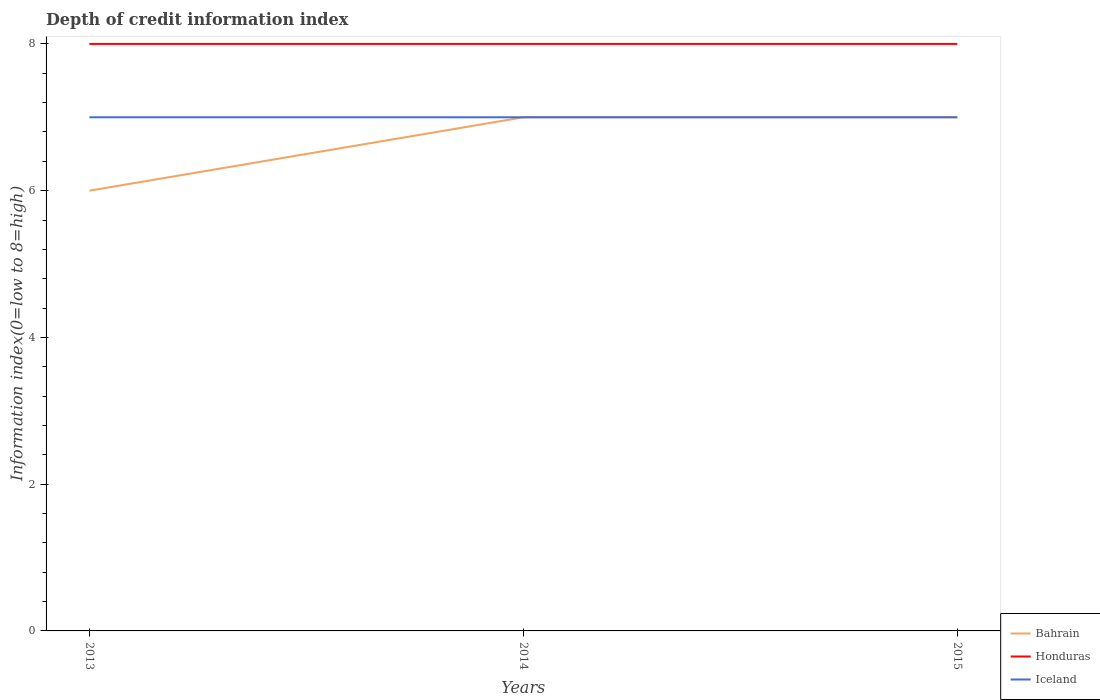How many different coloured lines are there?
Your answer should be very brief. 3. Across all years, what is the maximum information index in Bahrain?
Your answer should be compact. 6. What is the total information index in Bahrain in the graph?
Your response must be concise. 0. What is the difference between the highest and the second highest information index in Bahrain?
Make the answer very short. 1. What is the difference between the highest and the lowest information index in Honduras?
Your answer should be compact. 0. Does the graph contain grids?
Keep it short and to the point. No. Where does the legend appear in the graph?
Keep it short and to the point. Bottom right. How many legend labels are there?
Your answer should be very brief. 3. What is the title of the graph?
Give a very brief answer. Depth of credit information index. What is the label or title of the X-axis?
Offer a terse response. Years. What is the label or title of the Y-axis?
Give a very brief answer. Information index(0=low to 8=high). What is the Information index(0=low to 8=high) in Bahrain in 2013?
Offer a very short reply. 6. What is the Information index(0=low to 8=high) in Iceland in 2013?
Provide a succinct answer. 7. What is the Information index(0=low to 8=high) in Bahrain in 2014?
Provide a succinct answer. 7. What is the Information index(0=low to 8=high) in Honduras in 2014?
Your answer should be very brief. 8. What is the Information index(0=low to 8=high) of Iceland in 2014?
Offer a terse response. 7. What is the Information index(0=low to 8=high) of Bahrain in 2015?
Your response must be concise. 7. What is the Information index(0=low to 8=high) in Honduras in 2015?
Keep it short and to the point. 8. What is the total Information index(0=low to 8=high) of Honduras in the graph?
Ensure brevity in your answer.  24. What is the difference between the Information index(0=low to 8=high) in Bahrain in 2013 and that in 2014?
Provide a succinct answer. -1. What is the difference between the Information index(0=low to 8=high) of Bahrain in 2013 and that in 2015?
Keep it short and to the point. -1. What is the difference between the Information index(0=low to 8=high) of Honduras in 2013 and that in 2015?
Ensure brevity in your answer.  0. What is the difference between the Information index(0=low to 8=high) in Iceland in 2013 and that in 2015?
Make the answer very short. 0. What is the difference between the Information index(0=low to 8=high) in Honduras in 2014 and that in 2015?
Provide a short and direct response. 0. What is the difference between the Information index(0=low to 8=high) of Iceland in 2014 and that in 2015?
Your response must be concise. 0. What is the difference between the Information index(0=low to 8=high) in Bahrain in 2013 and the Information index(0=low to 8=high) in Honduras in 2014?
Your response must be concise. -2. What is the difference between the Information index(0=low to 8=high) in Bahrain in 2013 and the Information index(0=low to 8=high) in Iceland in 2014?
Your response must be concise. -1. What is the difference between the Information index(0=low to 8=high) of Honduras in 2013 and the Information index(0=low to 8=high) of Iceland in 2014?
Your answer should be compact. 1. What is the difference between the Information index(0=low to 8=high) of Bahrain in 2013 and the Information index(0=low to 8=high) of Iceland in 2015?
Provide a succinct answer. -1. What is the difference between the Information index(0=low to 8=high) in Honduras in 2013 and the Information index(0=low to 8=high) in Iceland in 2015?
Keep it short and to the point. 1. What is the difference between the Information index(0=low to 8=high) of Bahrain in 2014 and the Information index(0=low to 8=high) of Honduras in 2015?
Offer a very short reply. -1. What is the difference between the Information index(0=low to 8=high) in Bahrain in 2014 and the Information index(0=low to 8=high) in Iceland in 2015?
Give a very brief answer. 0. In the year 2013, what is the difference between the Information index(0=low to 8=high) in Bahrain and Information index(0=low to 8=high) in Honduras?
Your response must be concise. -2. In the year 2013, what is the difference between the Information index(0=low to 8=high) of Bahrain and Information index(0=low to 8=high) of Iceland?
Give a very brief answer. -1. In the year 2014, what is the difference between the Information index(0=low to 8=high) in Bahrain and Information index(0=low to 8=high) in Honduras?
Ensure brevity in your answer.  -1. In the year 2014, what is the difference between the Information index(0=low to 8=high) of Bahrain and Information index(0=low to 8=high) of Iceland?
Your response must be concise. 0. In the year 2014, what is the difference between the Information index(0=low to 8=high) in Honduras and Information index(0=low to 8=high) in Iceland?
Your answer should be compact. 1. In the year 2015, what is the difference between the Information index(0=low to 8=high) in Bahrain and Information index(0=low to 8=high) in Honduras?
Offer a very short reply. -1. In the year 2015, what is the difference between the Information index(0=low to 8=high) of Honduras and Information index(0=low to 8=high) of Iceland?
Provide a short and direct response. 1. What is the ratio of the Information index(0=low to 8=high) of Honduras in 2013 to that in 2014?
Make the answer very short. 1. What is the ratio of the Information index(0=low to 8=high) of Iceland in 2013 to that in 2014?
Provide a succinct answer. 1. What is the ratio of the Information index(0=low to 8=high) in Bahrain in 2013 to that in 2015?
Keep it short and to the point. 0.86. What is the ratio of the Information index(0=low to 8=high) in Honduras in 2013 to that in 2015?
Provide a succinct answer. 1. What is the ratio of the Information index(0=low to 8=high) of Iceland in 2013 to that in 2015?
Keep it short and to the point. 1. What is the ratio of the Information index(0=low to 8=high) in Bahrain in 2014 to that in 2015?
Your answer should be very brief. 1. What is the ratio of the Information index(0=low to 8=high) of Honduras in 2014 to that in 2015?
Make the answer very short. 1. What is the ratio of the Information index(0=low to 8=high) of Iceland in 2014 to that in 2015?
Ensure brevity in your answer.  1. What is the difference between the highest and the second highest Information index(0=low to 8=high) of Honduras?
Make the answer very short. 0. What is the difference between the highest and the lowest Information index(0=low to 8=high) of Honduras?
Your answer should be very brief. 0. 